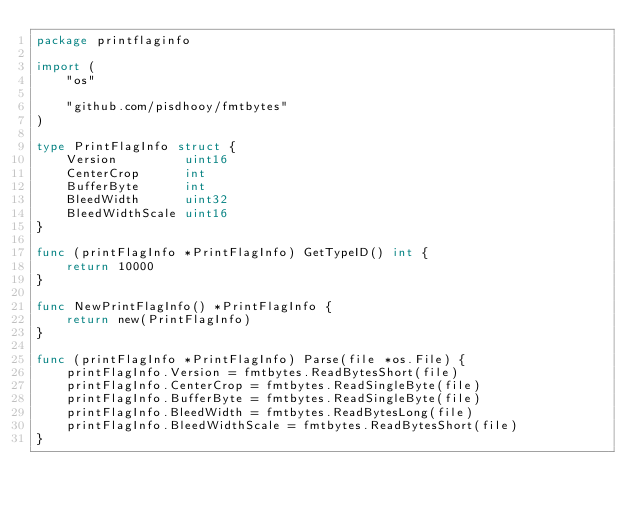<code> <loc_0><loc_0><loc_500><loc_500><_Go_>package printflaginfo

import (
	"os"

	"github.com/pisdhooy/fmtbytes"
)

type PrintFlagInfo struct {
	Version         uint16
	CenterCrop      int
	BufferByte      int
	BleedWidth      uint32
	BleedWidthScale uint16
}

func (printFlagInfo *PrintFlagInfo) GetTypeID() int {
	return 10000
}

func NewPrintFlagInfo() *PrintFlagInfo {
	return new(PrintFlagInfo)
}

func (printFlagInfo *PrintFlagInfo) Parse(file *os.File) {
	printFlagInfo.Version = fmtbytes.ReadBytesShort(file)
	printFlagInfo.CenterCrop = fmtbytes.ReadSingleByte(file)
	printFlagInfo.BufferByte = fmtbytes.ReadSingleByte(file)
	printFlagInfo.BleedWidth = fmtbytes.ReadBytesLong(file)
	printFlagInfo.BleedWidthScale = fmtbytes.ReadBytesShort(file)
}
</code> 